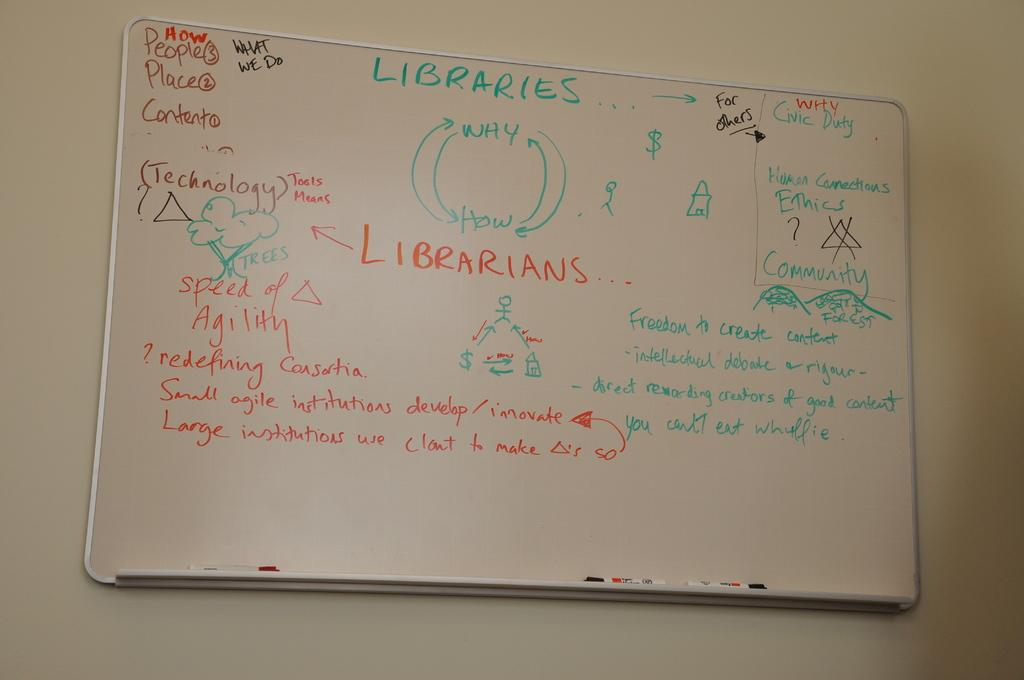What is the main object in the image? There is a white color board in the image. How is the color board positioned in the image? The board is fixed to the wall. What can be seen on the color board? There is text on the board. What is visible in the background of the image? There is a wall in the background of the image. How many pairs of shoes are hanging from the color board in the image? There are no shoes present in the image; it only features a white color board with text on it. 